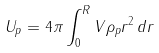<formula> <loc_0><loc_0><loc_500><loc_500>U _ { p } = 4 \pi \int _ { 0 } ^ { R } V \rho _ { p } r ^ { 2 } \, d r</formula> 